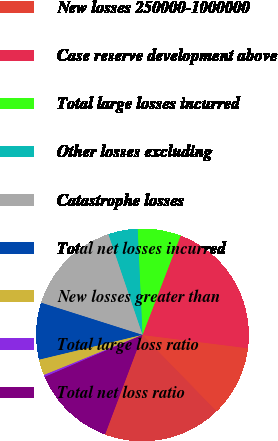Convert chart to OTSL. <chart><loc_0><loc_0><loc_500><loc_500><pie_chart><fcel>New losses 1000000-4000000<fcel>New losses 250000-1000000<fcel>Case reserve development above<fcel>Total large losses incurred<fcel>Other losses excluding<fcel>Catastrophe losses<fcel>Total net losses incurred<fcel>New losses greater than<fcel>Total large loss ratio<fcel>Total net loss ratio<nl><fcel>18.0%<fcel>10.73%<fcel>21.15%<fcel>6.56%<fcel>4.48%<fcel>14.9%<fcel>8.65%<fcel>2.4%<fcel>0.31%<fcel>12.81%<nl></chart> 